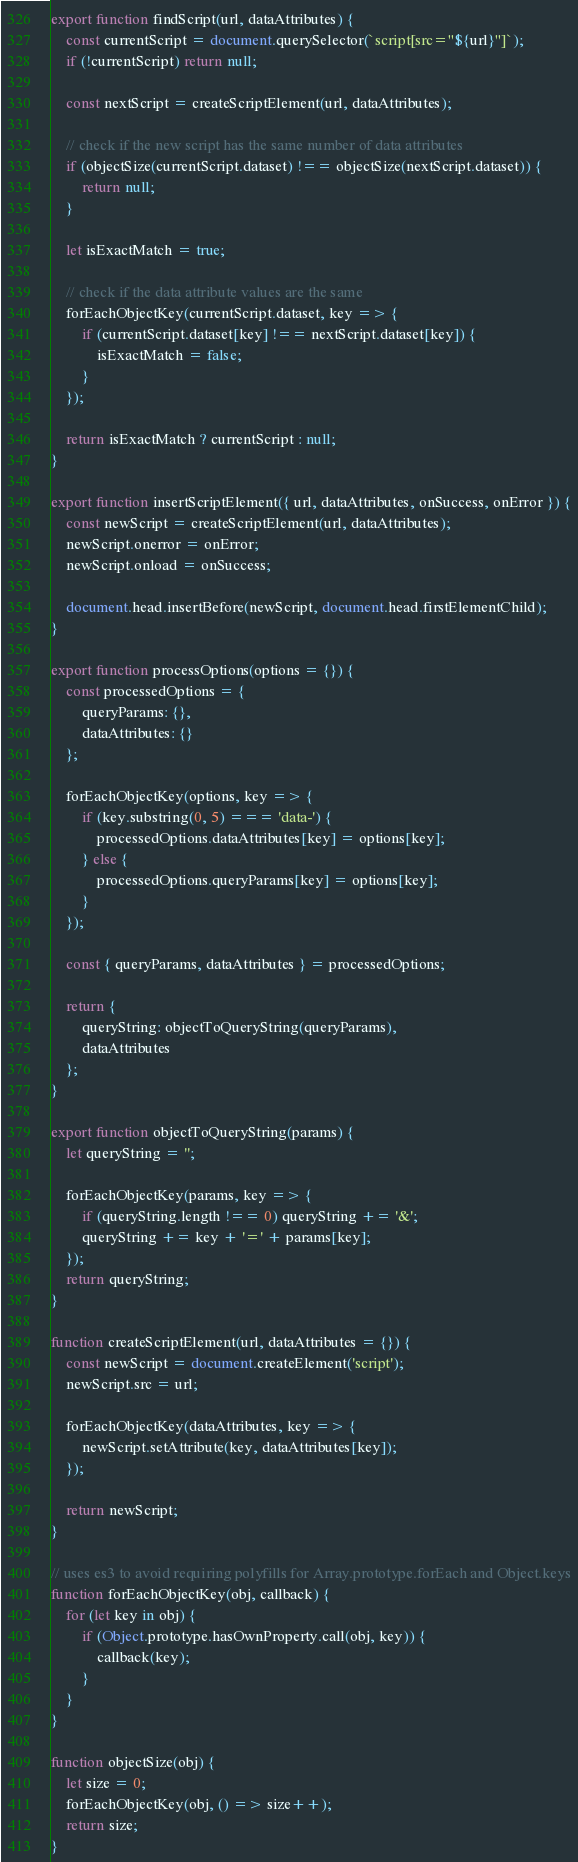<code> <loc_0><loc_0><loc_500><loc_500><_JavaScript_>export function findScript(url, dataAttributes) {
    const currentScript = document.querySelector(`script[src="${url}"]`);
    if (!currentScript) return null;

    const nextScript = createScriptElement(url, dataAttributes);

    // check if the new script has the same number of data attributes
    if (objectSize(currentScript.dataset) !== objectSize(nextScript.dataset)) {
        return null;
    }

    let isExactMatch = true;

    // check if the data attribute values are the same
    forEachObjectKey(currentScript.dataset, key => {
        if (currentScript.dataset[key] !== nextScript.dataset[key]) {
            isExactMatch = false;
        }
    });

    return isExactMatch ? currentScript : null;
}

export function insertScriptElement({ url, dataAttributes, onSuccess, onError }) {
    const newScript = createScriptElement(url, dataAttributes);
    newScript.onerror = onError;
    newScript.onload = onSuccess;

    document.head.insertBefore(newScript, document.head.firstElementChild);
}

export function processOptions(options = {}) {
    const processedOptions = {
        queryParams: {},
        dataAttributes: {}
    };

    forEachObjectKey(options, key => {
        if (key.substring(0, 5) === 'data-') {
            processedOptions.dataAttributes[key] = options[key];
        } else {
            processedOptions.queryParams[key] = options[key];
        }
    });

    const { queryParams, dataAttributes } = processedOptions;

    return {
        queryString: objectToQueryString(queryParams),
        dataAttributes
    };
}

export function objectToQueryString(params) {
    let queryString = '';

    forEachObjectKey(params, key => {
        if (queryString.length !== 0) queryString += '&';
        queryString += key + '=' + params[key];
    });
    return queryString;
}

function createScriptElement(url, dataAttributes = {}) {
    const newScript = document.createElement('script');
    newScript.src = url;

    forEachObjectKey(dataAttributes, key => {
        newScript.setAttribute(key, dataAttributes[key]);
    });

    return newScript;
}

// uses es3 to avoid requiring polyfills for Array.prototype.forEach and Object.keys
function forEachObjectKey(obj, callback) {
    for (let key in obj) {
        if (Object.prototype.hasOwnProperty.call(obj, key)) {
            callback(key);
        }
    }
}

function objectSize(obj) {
    let size = 0;
    forEachObjectKey(obj, () => size++);
    return size;
}
</code> 